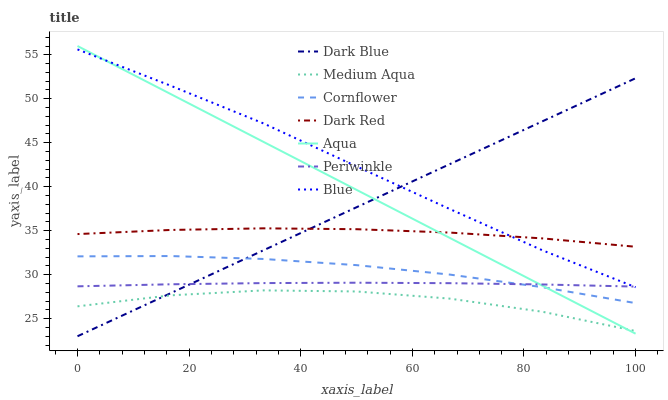Does Medium Aqua have the minimum area under the curve?
Answer yes or no. Yes. Does Blue have the maximum area under the curve?
Answer yes or no. Yes. Does Cornflower have the minimum area under the curve?
Answer yes or no. No. Does Cornflower have the maximum area under the curve?
Answer yes or no. No. Is Aqua the smoothest?
Answer yes or no. Yes. Is Medium Aqua the roughest?
Answer yes or no. Yes. Is Cornflower the smoothest?
Answer yes or no. No. Is Cornflower the roughest?
Answer yes or no. No. Does Dark Blue have the lowest value?
Answer yes or no. Yes. Does Cornflower have the lowest value?
Answer yes or no. No. Does Aqua have the highest value?
Answer yes or no. Yes. Does Cornflower have the highest value?
Answer yes or no. No. Is Medium Aqua less than Dark Red?
Answer yes or no. Yes. Is Blue greater than Cornflower?
Answer yes or no. Yes. Does Dark Blue intersect Medium Aqua?
Answer yes or no. Yes. Is Dark Blue less than Medium Aqua?
Answer yes or no. No. Is Dark Blue greater than Medium Aqua?
Answer yes or no. No. Does Medium Aqua intersect Dark Red?
Answer yes or no. No. 